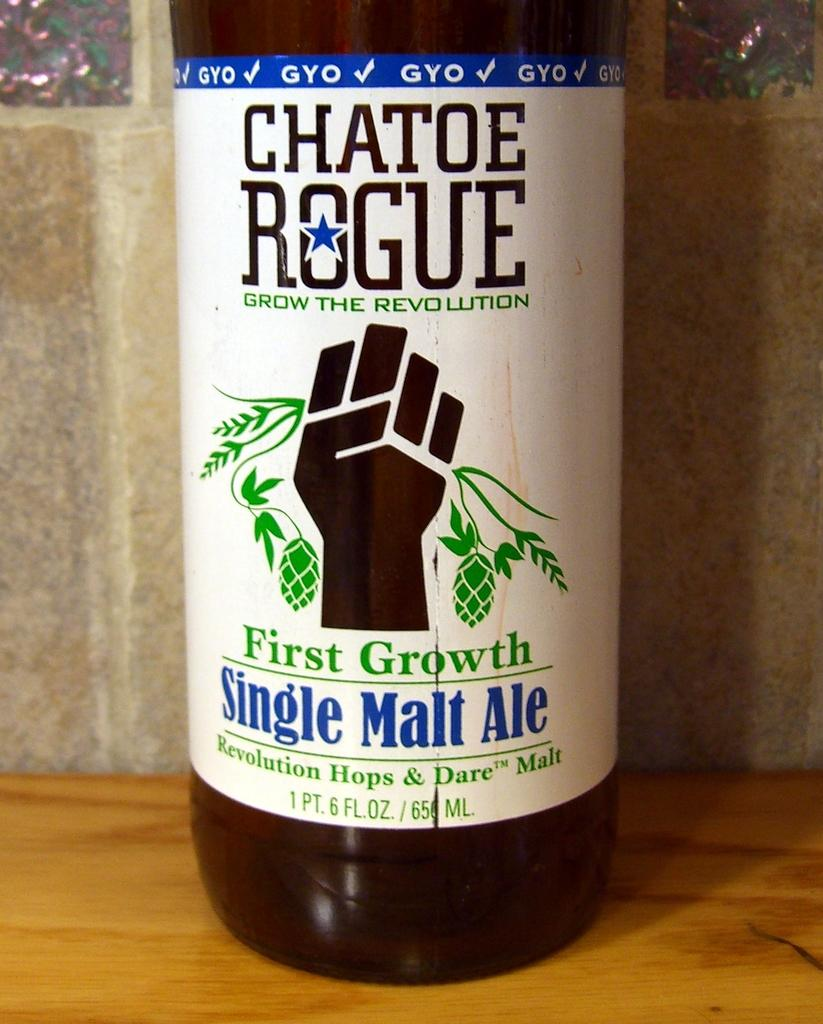<image>
Provide a brief description of the given image. a bottle of First Growth single malt ale on the table 